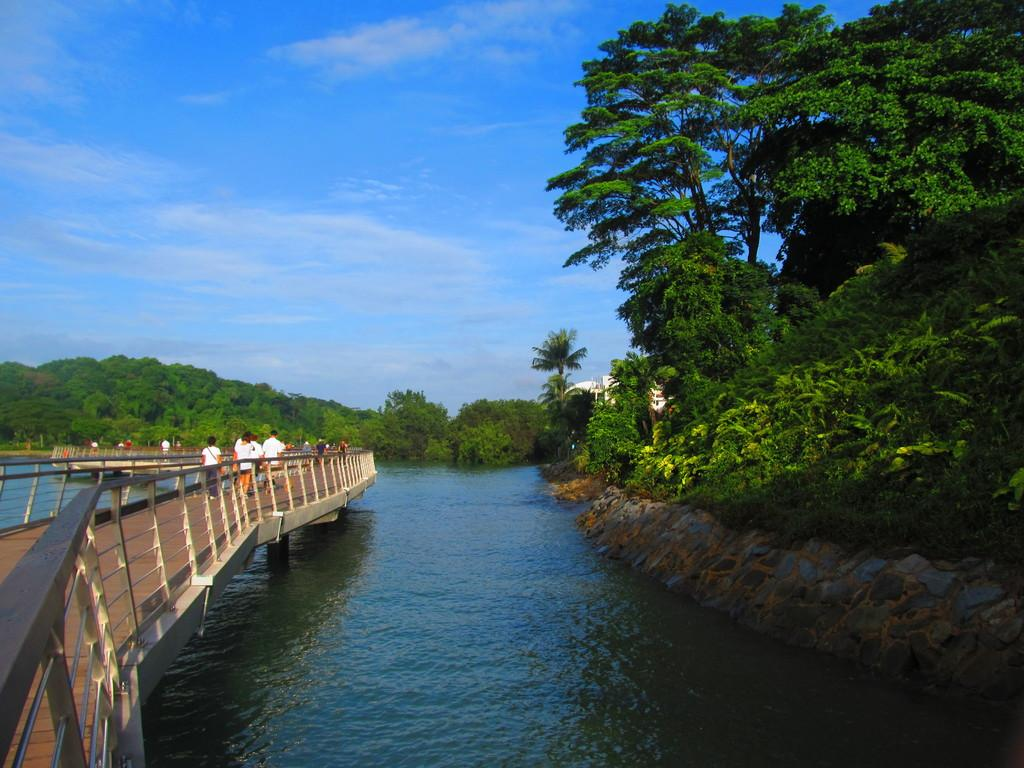What are the people in the image doing? The people in the image are walking on a path. What can be seen alongside the path? There are railings in the image. What type of structure is visible in the image? There is a house in the image. What type of vegetation is present in the image? Plants and trees are visible in the image. What natural feature can be seen in the image? There is a river in the image. What is visible in the sky in the image? The sky is visible in the image. How many islands can be seen in the image? There are no islands visible in the image. 